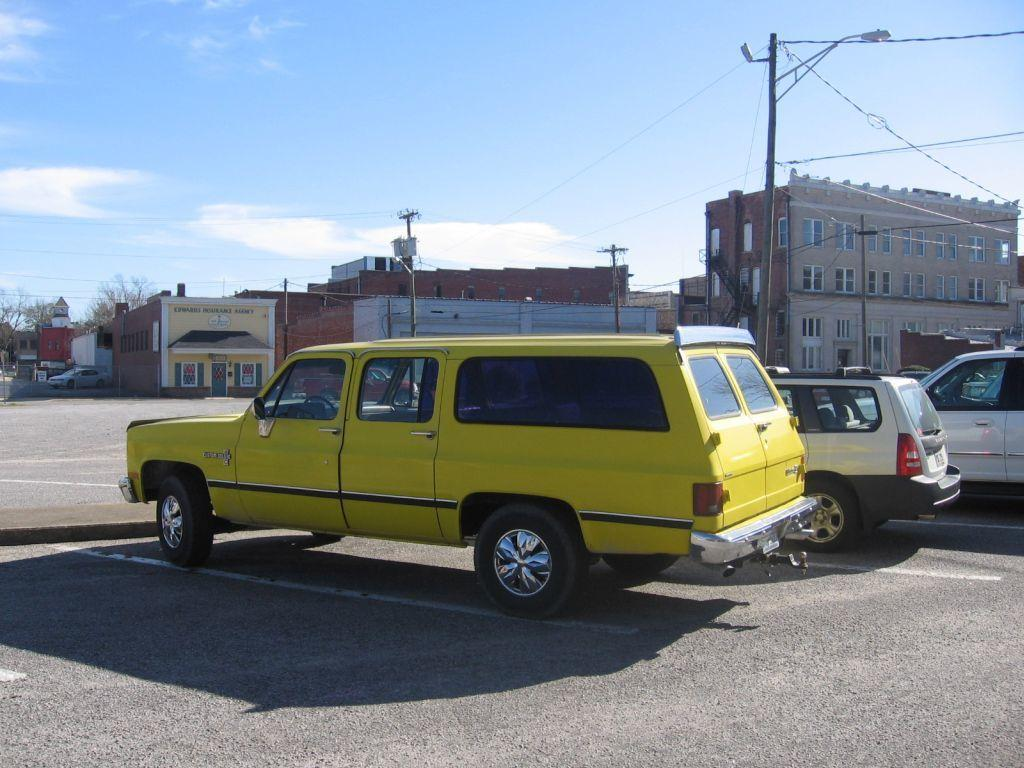What can be seen in the sky in the image? The sky with clouds is visible in the image. What structures are present in the image related to electricity? Electric poles and electric cables are present in the image. What type of lighting is visible in the image? Street lights are visible in the image. What type of vegetation is present in the image? Trees are present in the image. What type of buildings can be seen in the image? Buildings are visible in the image. What type of establishments are present in the image? Stores are present in the image. What type of transportation is on the road in the image? Motor vehicles are on the road in the image. How many toes are visible on the street lights in the image? There are no toes visible on the street lights in the image; they are lighting structures. What idea does the image represent about the future of transportation? The image does not represent any specific idea about the future of transportation; it simply shows motor vehicles on the road. 